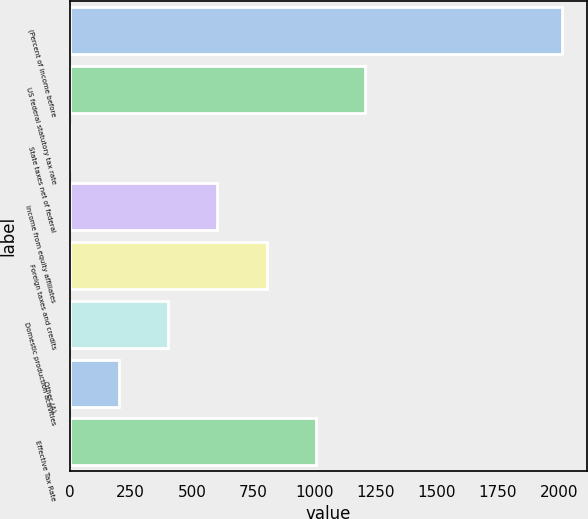Convert chart. <chart><loc_0><loc_0><loc_500><loc_500><bar_chart><fcel>(Percent of income before<fcel>US federal statutory tax rate<fcel>State taxes net of federal<fcel>Income from equity affiliates<fcel>Foreign taxes and credits<fcel>Domestic production activities<fcel>Other (A)<fcel>Effective Tax Rate<nl><fcel>2012<fcel>1207.48<fcel>0.7<fcel>604.09<fcel>805.22<fcel>402.96<fcel>201.83<fcel>1006.35<nl></chart> 